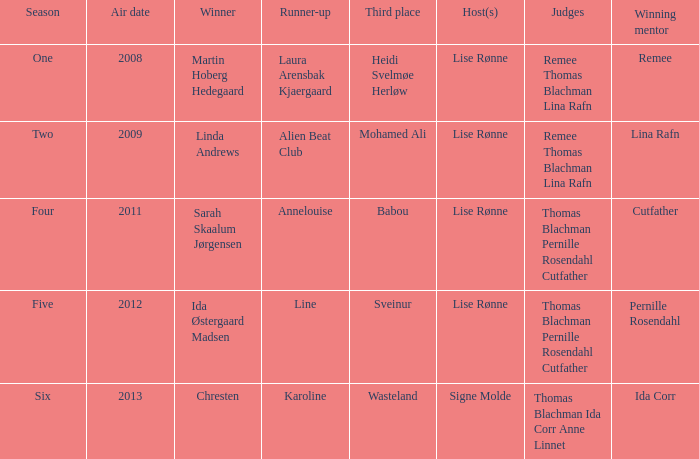Which season did Ida Corr win? Six. 